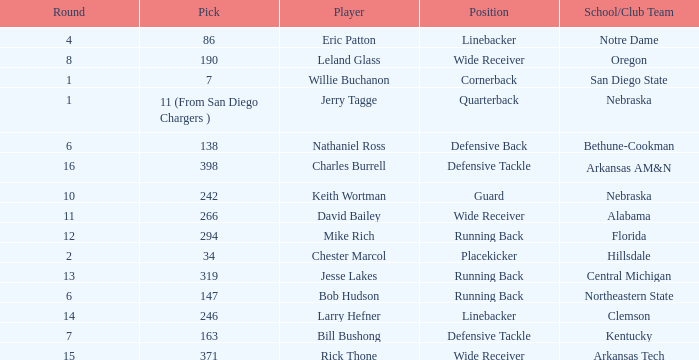Which round has a position that is cornerback? 1.0. 